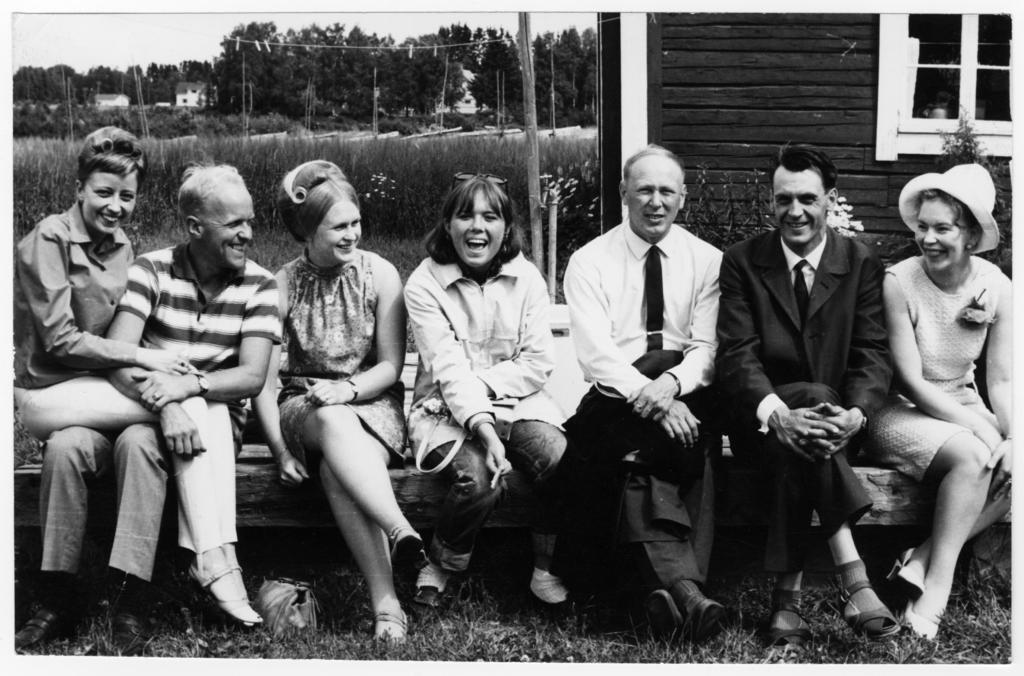Could you give a brief overview of what you see in this image? It looks like an old black and white picture. We can see there are a group of people sitting on a bench and behind the people there are plants, houses, trees and a sky. 